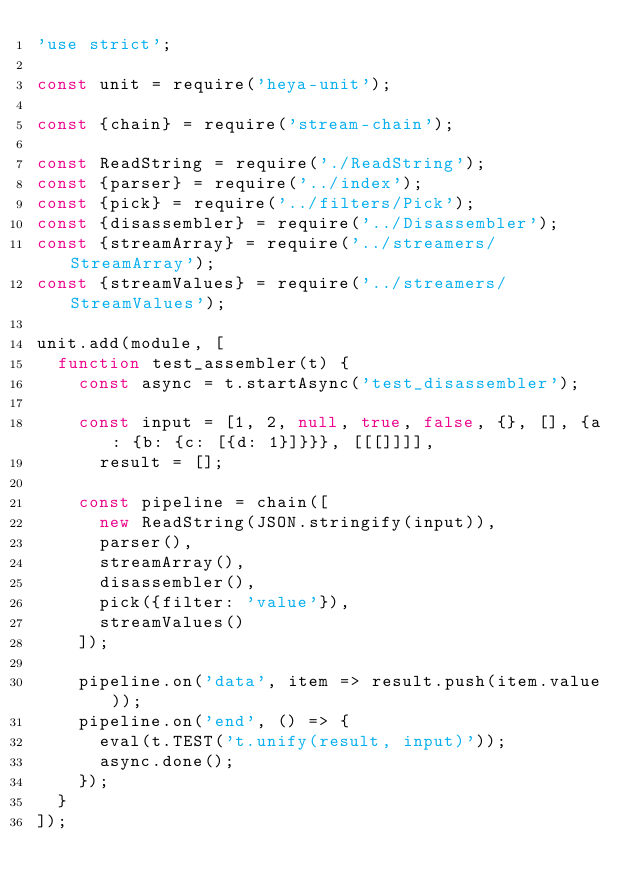<code> <loc_0><loc_0><loc_500><loc_500><_JavaScript_>'use strict';

const unit = require('heya-unit');

const {chain} = require('stream-chain');

const ReadString = require('./ReadString');
const {parser} = require('../index');
const {pick} = require('../filters/Pick');
const {disassembler} = require('../Disassembler');
const {streamArray} = require('../streamers/StreamArray');
const {streamValues} = require('../streamers/StreamValues');

unit.add(module, [
  function test_assembler(t) {
    const async = t.startAsync('test_disassembler');

    const input = [1, 2, null, true, false, {}, [], {a: {b: {c: [{d: 1}]}}}, [[[]]]],
      result = [];

    const pipeline = chain([
      new ReadString(JSON.stringify(input)),
      parser(),
      streamArray(),
      disassembler(),
      pick({filter: 'value'}),
      streamValues()
    ]);

    pipeline.on('data', item => result.push(item.value));
    pipeline.on('end', () => {
      eval(t.TEST('t.unify(result, input)'));
      async.done();
    });
  }
]);
</code> 